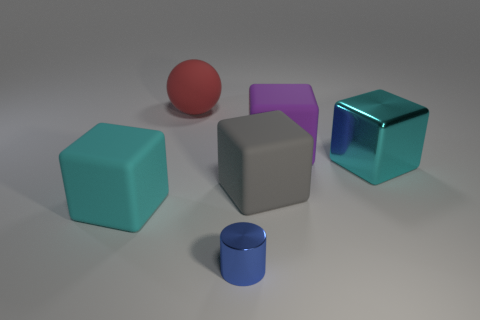What color is the cube that is to the left of the tiny blue metal cylinder that is in front of the red sphere?
Your answer should be compact. Cyan. There is a big object left of the large matte ball; is its shape the same as the big thing right of the big purple matte thing?
Keep it short and to the point. Yes. The gray matte thing that is the same size as the cyan shiny thing is what shape?
Give a very brief answer. Cube. There is a large ball that is the same material as the gray thing; what color is it?
Offer a terse response. Red. Is the shape of the gray matte thing the same as the big cyan object that is to the right of the blue cylinder?
Offer a terse response. Yes. What is the material of the other thing that is the same color as the big metal object?
Offer a very short reply. Rubber. There is a gray block that is the same size as the red matte thing; what material is it?
Keep it short and to the point. Rubber. Are there any big blocks that have the same color as the matte sphere?
Your response must be concise. No. What shape is the large matte object that is left of the gray matte block and in front of the large red rubber sphere?
Your answer should be compact. Cube. How many red spheres have the same material as the tiny blue cylinder?
Provide a succinct answer. 0. 